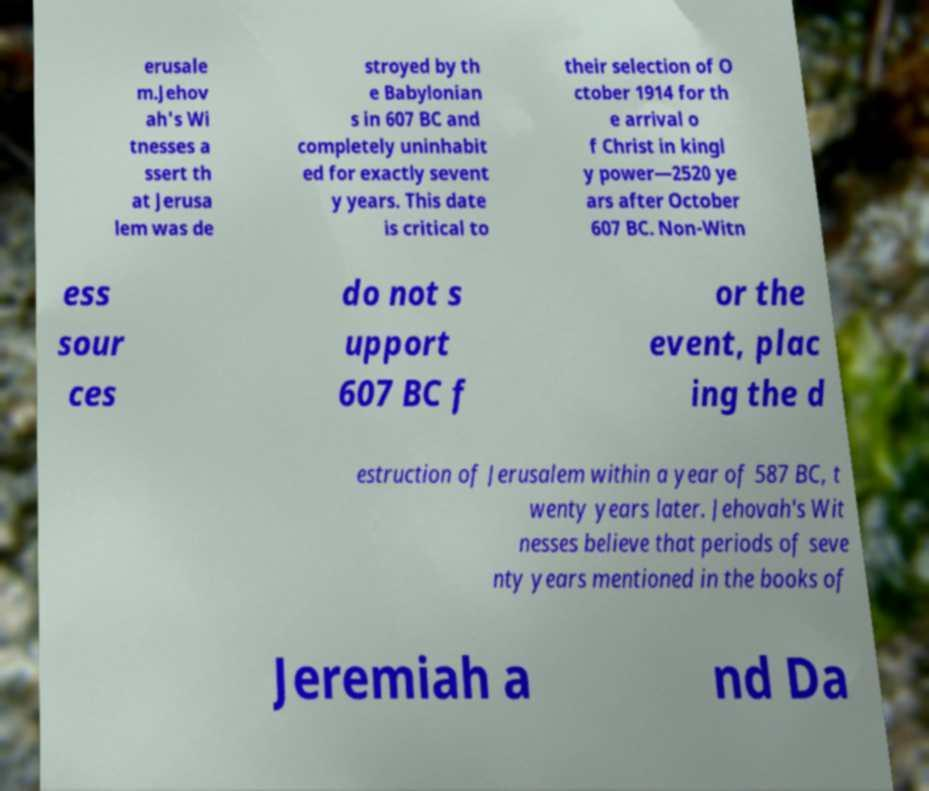There's text embedded in this image that I need extracted. Can you transcribe it verbatim? erusale m.Jehov ah's Wi tnesses a ssert th at Jerusa lem was de stroyed by th e Babylonian s in 607 BC and completely uninhabit ed for exactly sevent y years. This date is critical to their selection of O ctober 1914 for th e arrival o f Christ in kingl y power—2520 ye ars after October 607 BC. Non-Witn ess sour ces do not s upport 607 BC f or the event, plac ing the d estruction of Jerusalem within a year of 587 BC, t wenty years later. Jehovah's Wit nesses believe that periods of seve nty years mentioned in the books of Jeremiah a nd Da 